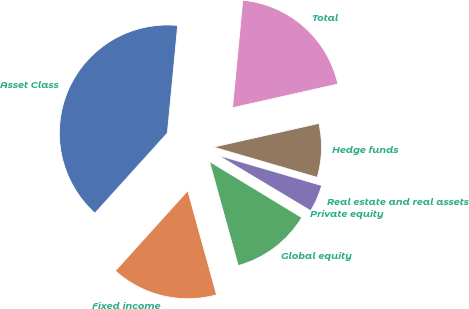Convert chart to OTSL. <chart><loc_0><loc_0><loc_500><loc_500><pie_chart><fcel>Asset Class<fcel>Fixed income<fcel>Global equity<fcel>Private equity<fcel>Real estate and real assets<fcel>Hedge funds<fcel>Total<nl><fcel>39.82%<fcel>15.99%<fcel>12.02%<fcel>0.1%<fcel>4.07%<fcel>8.04%<fcel>19.96%<nl></chart> 